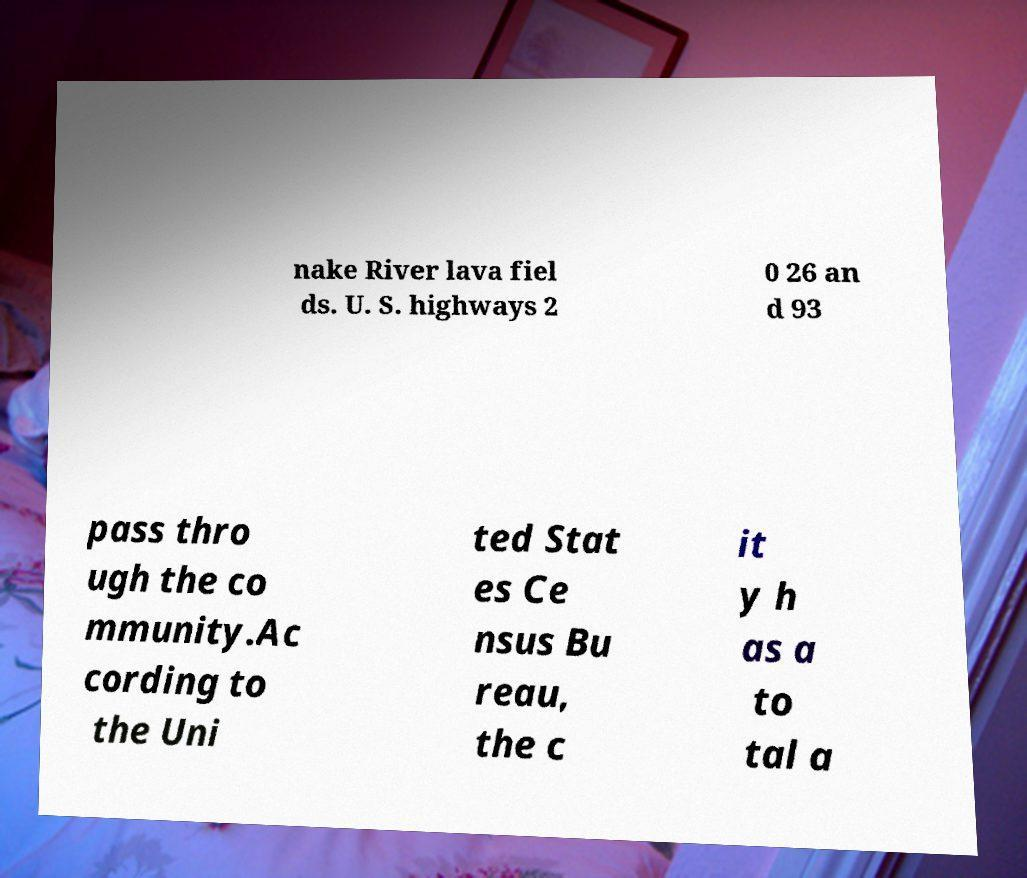For documentation purposes, I need the text within this image transcribed. Could you provide that? nake River lava fiel ds. U. S. highways 2 0 26 an d 93 pass thro ugh the co mmunity.Ac cording to the Uni ted Stat es Ce nsus Bu reau, the c it y h as a to tal a 